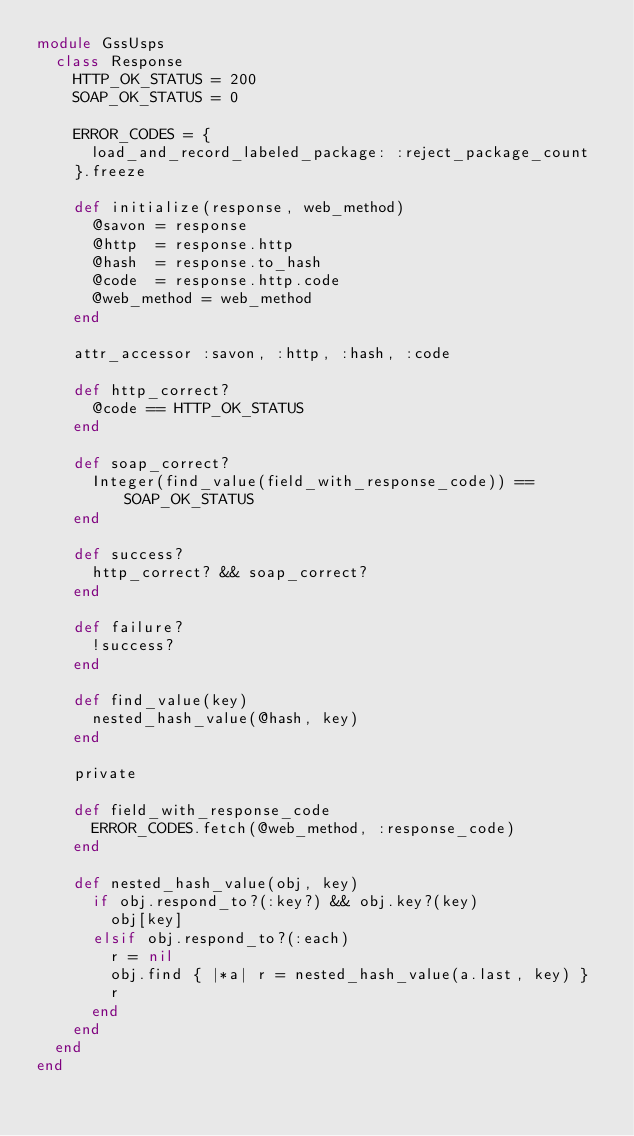<code> <loc_0><loc_0><loc_500><loc_500><_Ruby_>module GssUsps
  class Response
    HTTP_OK_STATUS = 200
    SOAP_OK_STATUS = 0

    ERROR_CODES = {
      load_and_record_labeled_package: :reject_package_count
    }.freeze

    def initialize(response, web_method)
      @savon = response
      @http  = response.http
      @hash  = response.to_hash
      @code  = response.http.code
      @web_method = web_method
    end

    attr_accessor :savon, :http, :hash, :code

    def http_correct?
      @code == HTTP_OK_STATUS
    end

    def soap_correct?
      Integer(find_value(field_with_response_code)) == SOAP_OK_STATUS
    end

    def success?
      http_correct? && soap_correct?
    end

    def failure?
      !success?
    end

    def find_value(key)
      nested_hash_value(@hash, key)
    end

    private

    def field_with_response_code
      ERROR_CODES.fetch(@web_method, :response_code)
    end

    def nested_hash_value(obj, key)
      if obj.respond_to?(:key?) && obj.key?(key)
        obj[key]
      elsif obj.respond_to?(:each)
        r = nil
        obj.find { |*a| r = nested_hash_value(a.last, key) }
        r
      end
    end
  end
end
</code> 